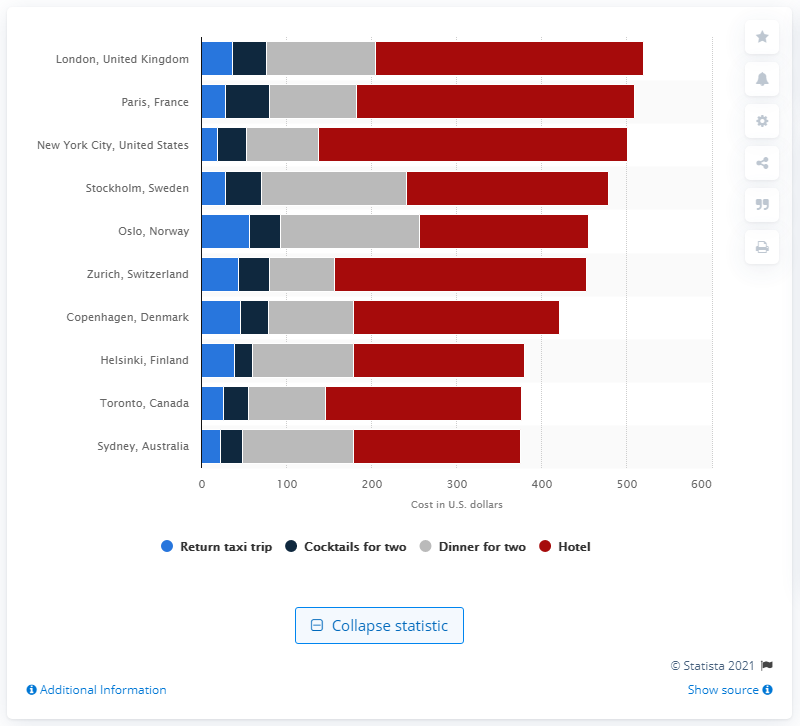Identify some key points in this picture. The average cost of a two-course meal for two people in New York City was 84.62 dollars. 